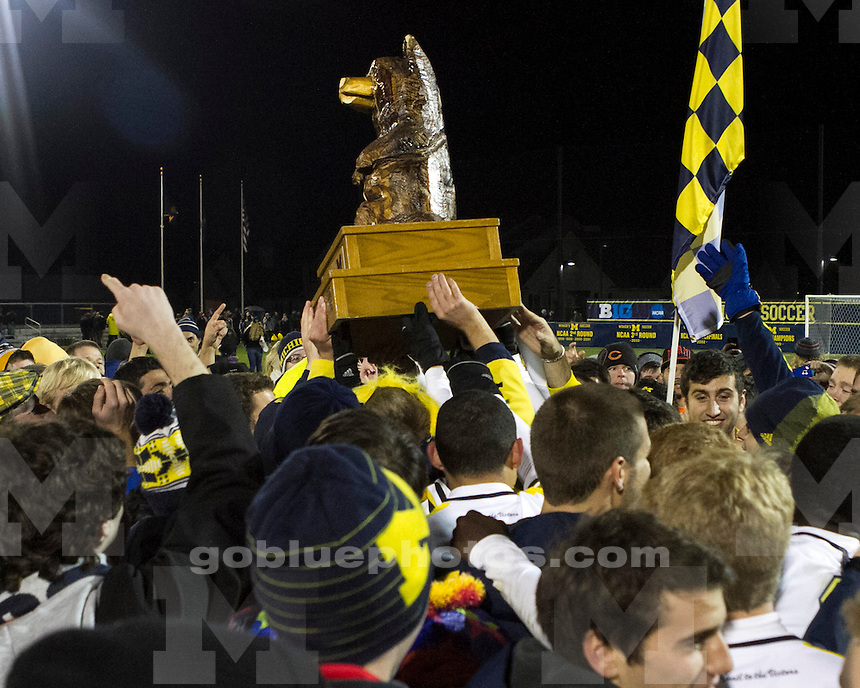What might the significance of the golden wolverine trophy be to the group of people in the image? The golden wolverine trophy in the image symbolizes a considerable achievement, likely in the context of collegiate sports, where such trophies are traditionally celebrated. The joyful expressions and participatory energy of the crowd, composed largely of individuals wearing colors and symbols associated with the University of Michigan (notably the 'M' logos), imply the trophy is a prestigious award within this community. It might represent triumph in a key sports event, underpinning themes of community pride, sportsmanship, and collective identity. This event is not just a win, but a moment of shared victory and identity reinforcement among students and fans of the university. 